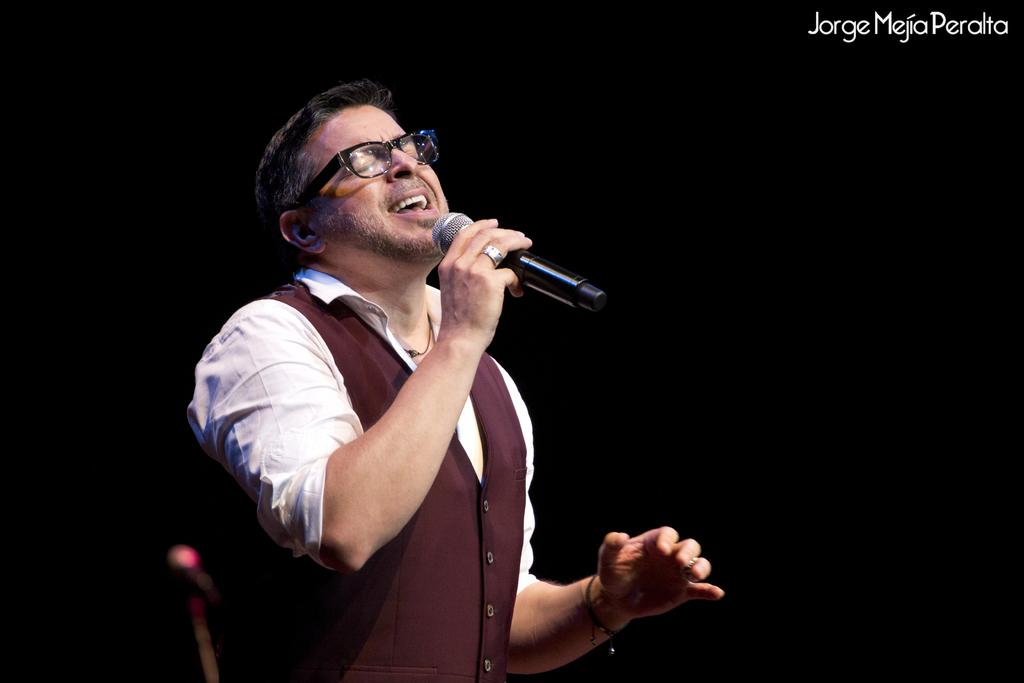Who is the main subject in the image? There is a man in the image. Where is the man positioned in the image? The man is standing in the center. What is the man holding in his right hand? The man is holding a microphone in his right hand. What is the man doing in the image? The man is singing a song. What type of credit card is the man using to pay for the attraction in the image? There is no credit card or attraction present in the image; the man is holding a microphone and singing a song. 